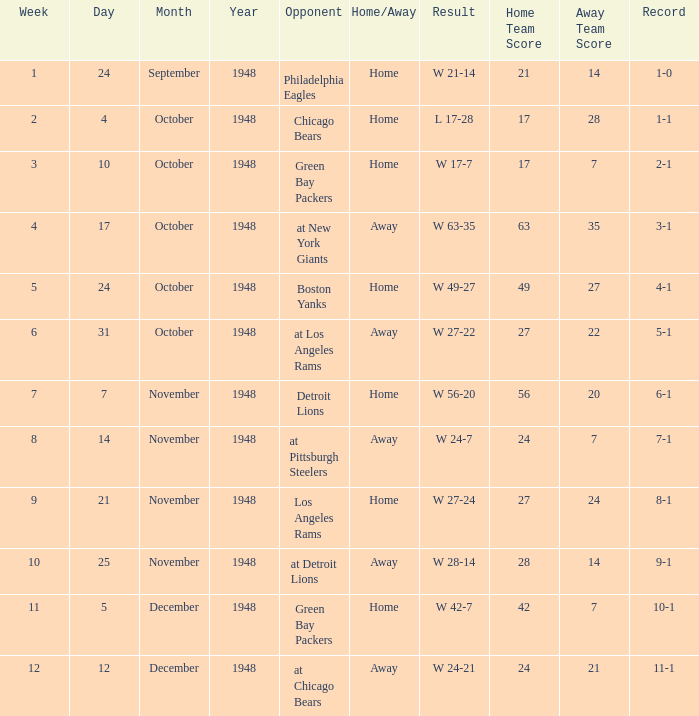What was the record for December 5, 1948? 10-1. 